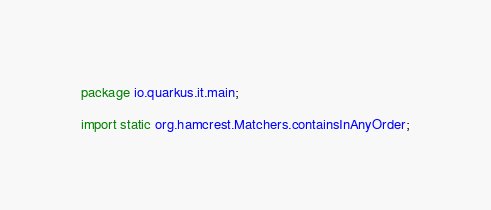Convert code to text. <code><loc_0><loc_0><loc_500><loc_500><_Java_>package io.quarkus.it.main;

import static org.hamcrest.Matchers.containsInAnyOrder;</code> 